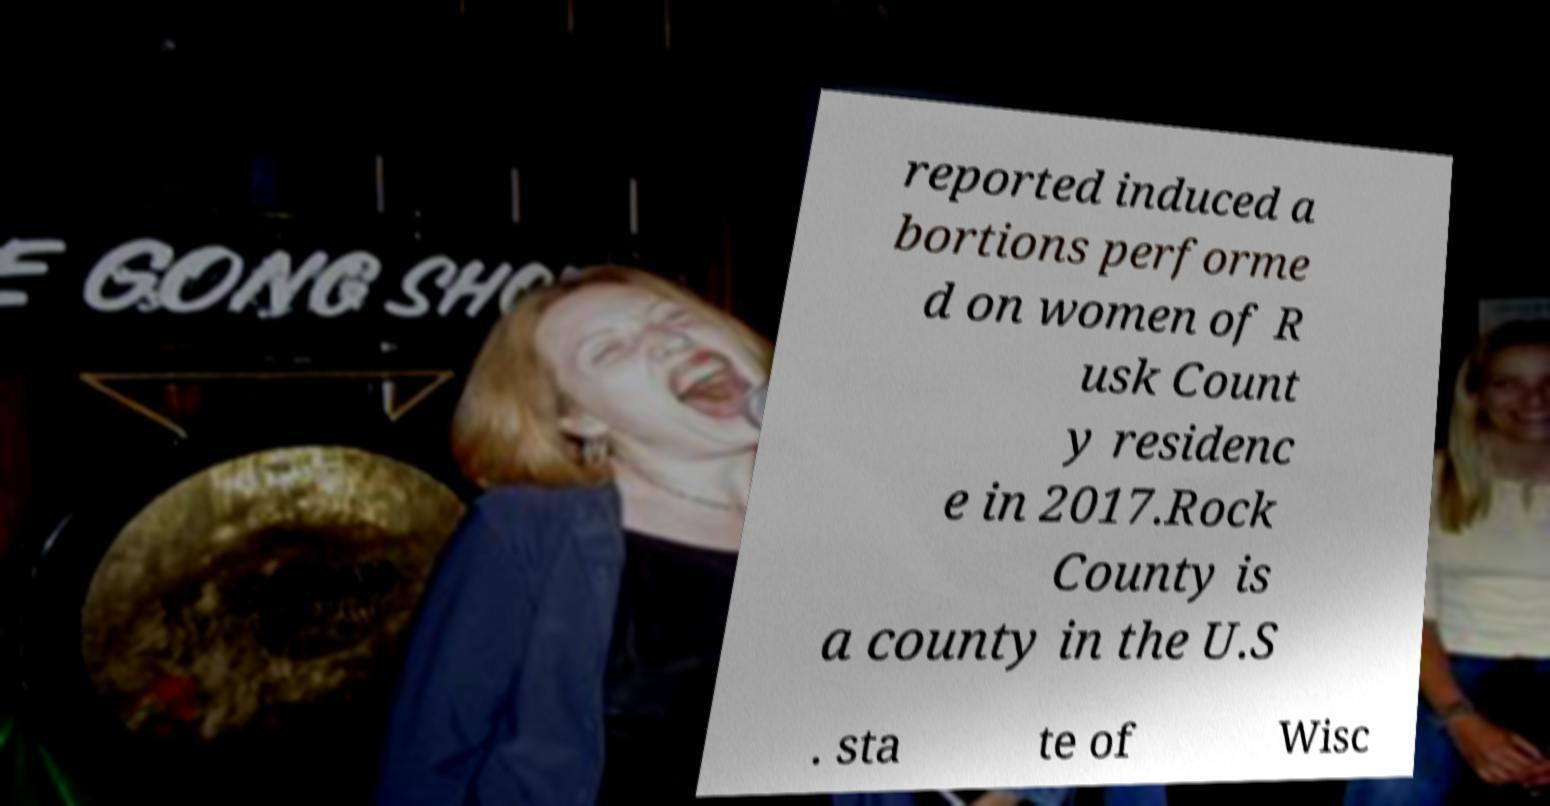What messages or text are displayed in this image? I need them in a readable, typed format. reported induced a bortions performe d on women of R usk Count y residenc e in 2017.Rock County is a county in the U.S . sta te of Wisc 